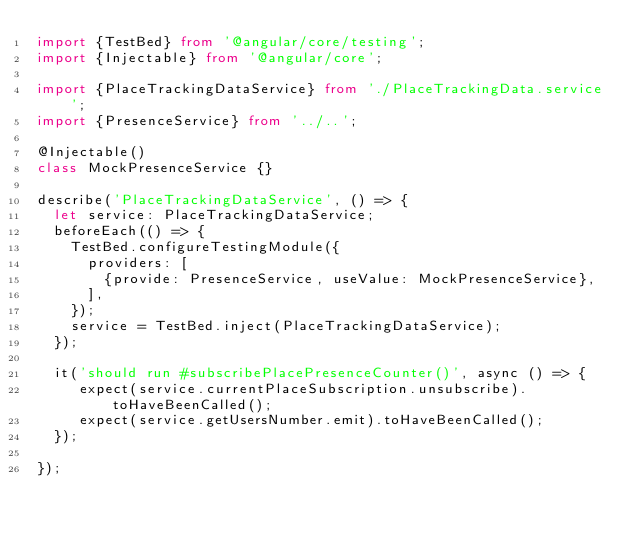Convert code to text. <code><loc_0><loc_0><loc_500><loc_500><_TypeScript_>import {TestBed} from '@angular/core/testing';
import {Injectable} from '@angular/core';

import {PlaceTrackingDataService} from './PlaceTrackingData.service';
import {PresenceService} from '../..';

@Injectable()
class MockPresenceService {}

describe('PlaceTrackingDataService', () => {
  let service: PlaceTrackingDataService;
  beforeEach(() => {
    TestBed.configureTestingModule({
      providers: [
        {provide: PresenceService, useValue: MockPresenceService},
      ],
    });
    service = TestBed.inject(PlaceTrackingDataService);
  });

  it('should run #subscribePlacePresenceCounter()', async () => {
     expect(service.currentPlaceSubscription.unsubscribe).toHaveBeenCalled();
     expect(service.getUsersNumber.emit).toHaveBeenCalled();
  });

});
</code> 